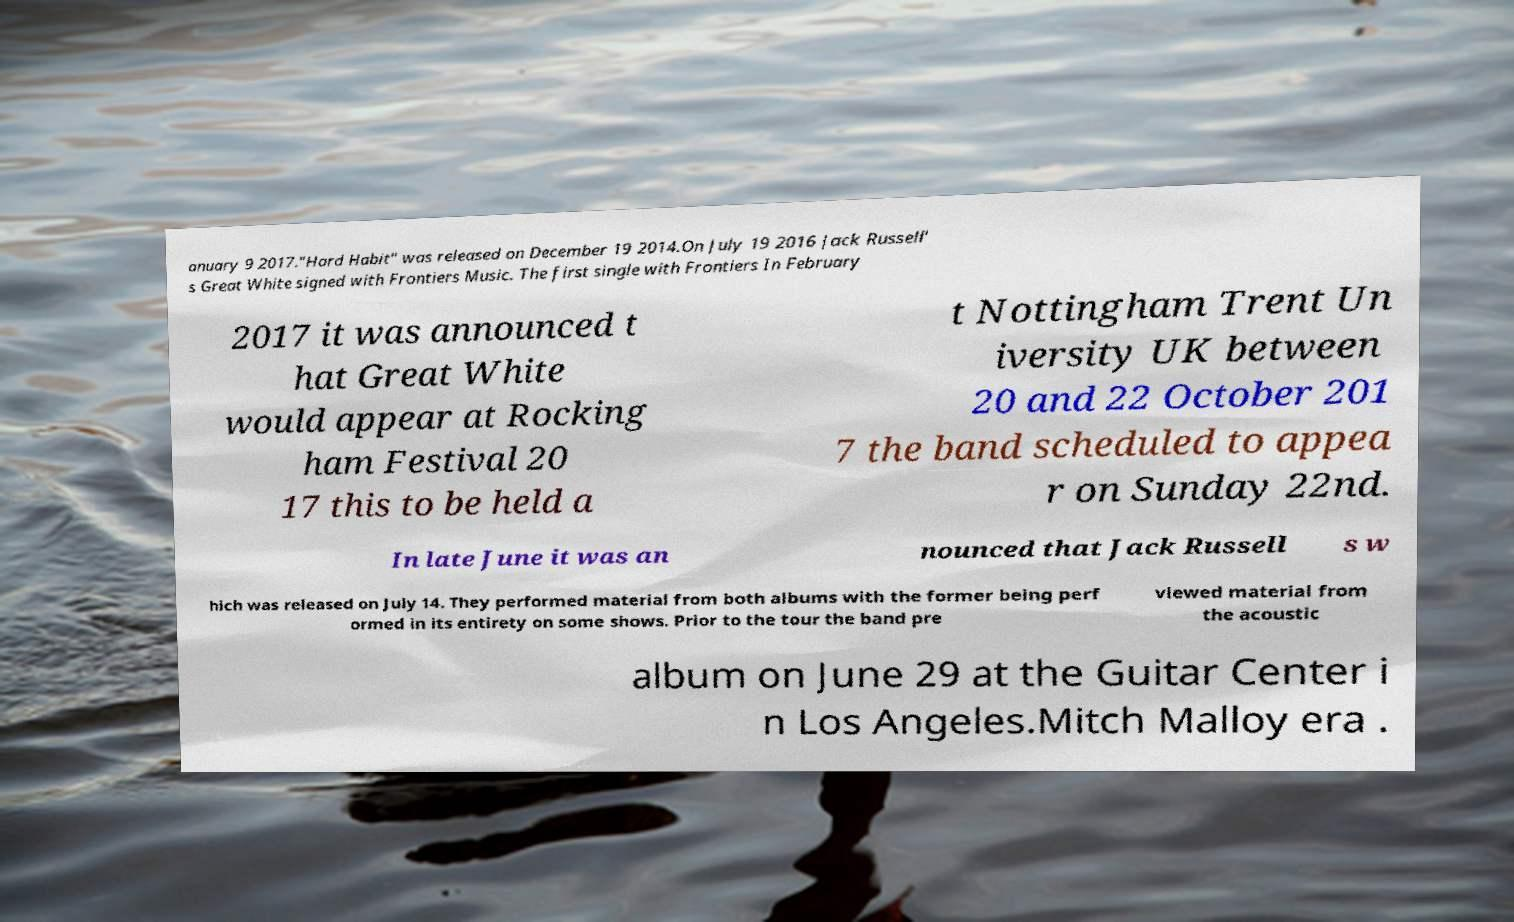Please identify and transcribe the text found in this image. anuary 9 2017."Hard Habit" was released on December 19 2014.On July 19 2016 Jack Russell' s Great White signed with Frontiers Music. The first single with Frontiers In February 2017 it was announced t hat Great White would appear at Rocking ham Festival 20 17 this to be held a t Nottingham Trent Un iversity UK between 20 and 22 October 201 7 the band scheduled to appea r on Sunday 22nd. In late June it was an nounced that Jack Russell s w hich was released on July 14. They performed material from both albums with the former being perf ormed in its entirety on some shows. Prior to the tour the band pre viewed material from the acoustic album on June 29 at the Guitar Center i n Los Angeles.Mitch Malloy era . 